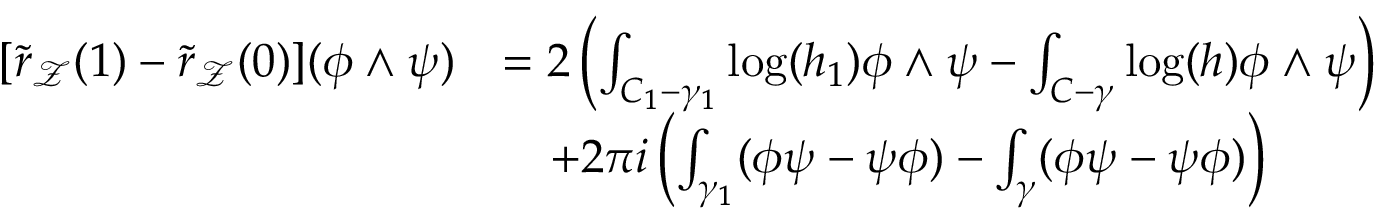Convert formula to latex. <formula><loc_0><loc_0><loc_500><loc_500>\begin{array} { r l } { [ \tilde { r } _ { \mathcal { Z } } ( 1 ) - \tilde { r } _ { \mathcal { Z } } ( 0 ) ] ( \phi \wedge \psi ) } & { = 2 \left ( \int _ { C _ { 1 } - \gamma _ { 1 } } \log ( h _ { 1 } ) \phi \wedge \psi - \int _ { C - \gamma } \log ( h ) \phi \wedge \psi \right ) } \\ & { \quad + 2 \pi i \left ( \int _ { \gamma _ { 1 } } ( \phi \psi - \psi \phi ) - \int _ { \gamma } ( \phi \psi - \psi \phi ) \right ) } \end{array}</formula> 